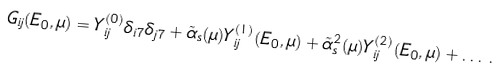<formula> <loc_0><loc_0><loc_500><loc_500>G _ { i j } ( E _ { 0 } , \mu ) = Y _ { i j } ^ { ( 0 ) } \delta _ { i 7 } \delta _ { j 7 } + \tilde { \alpha } _ { s } ( \mu ) Y _ { i j } ^ { ( 1 ) } ( E _ { 0 } , \mu ) + \tilde { \alpha } _ { s } ^ { 2 } ( \mu ) Y _ { i j } ^ { ( 2 ) } ( E _ { 0 } , \mu ) + \dots \, .</formula> 